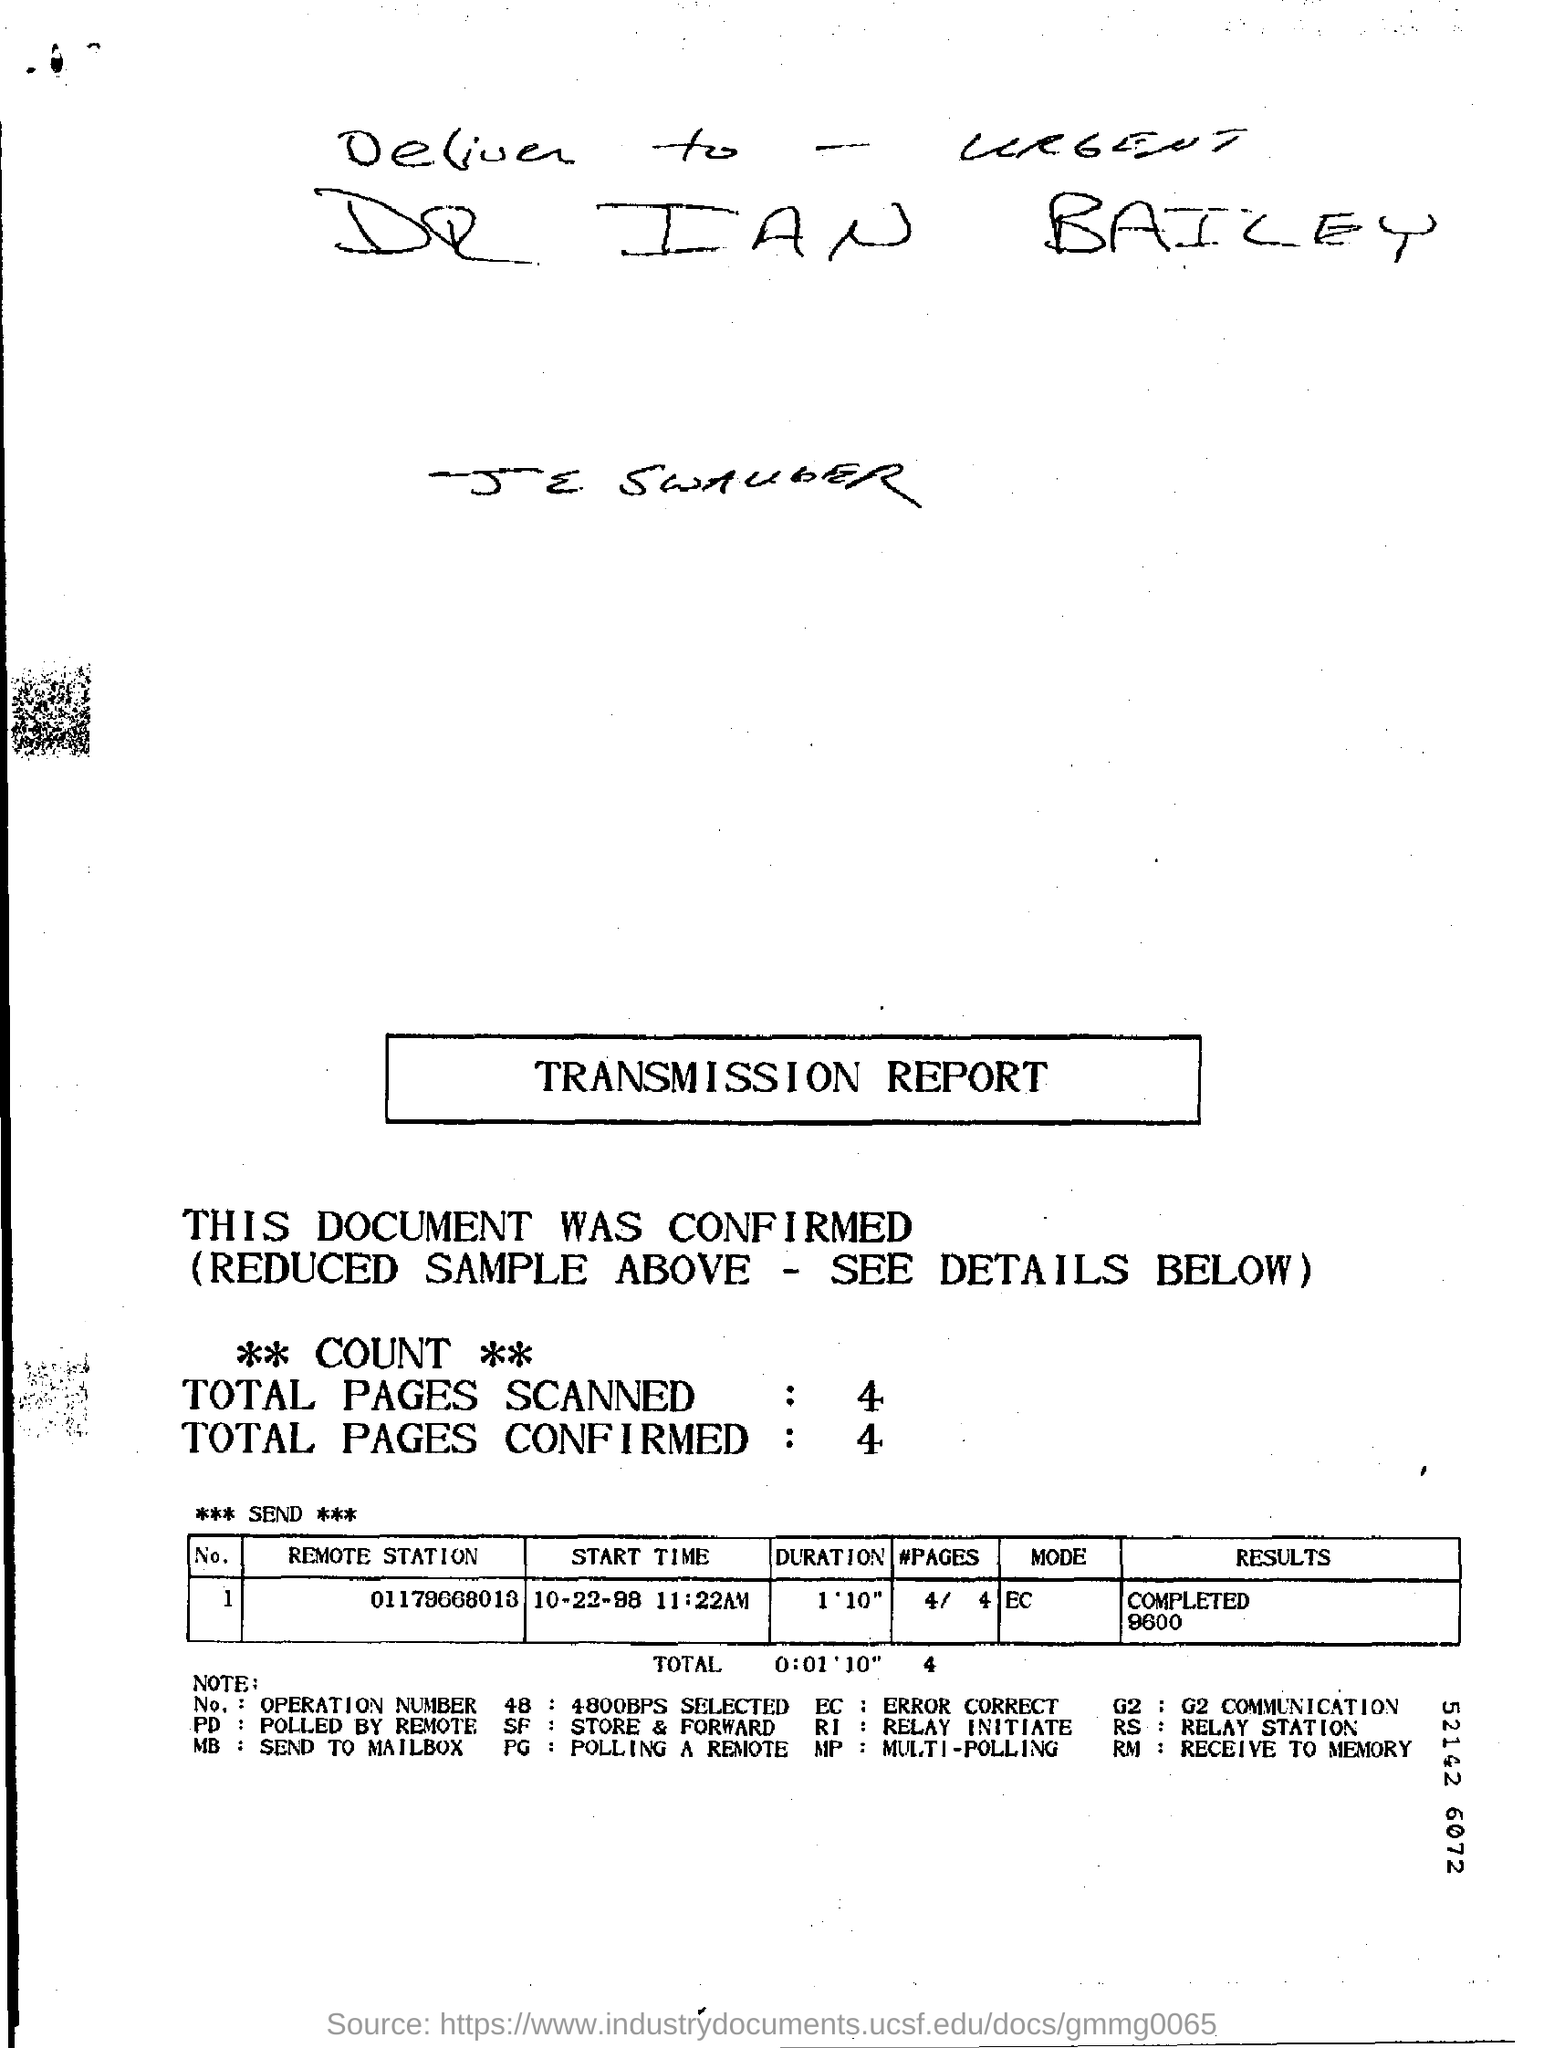Indicate a few pertinent items in this graphic. The mode of transmission for COVID-19 is unknown. 